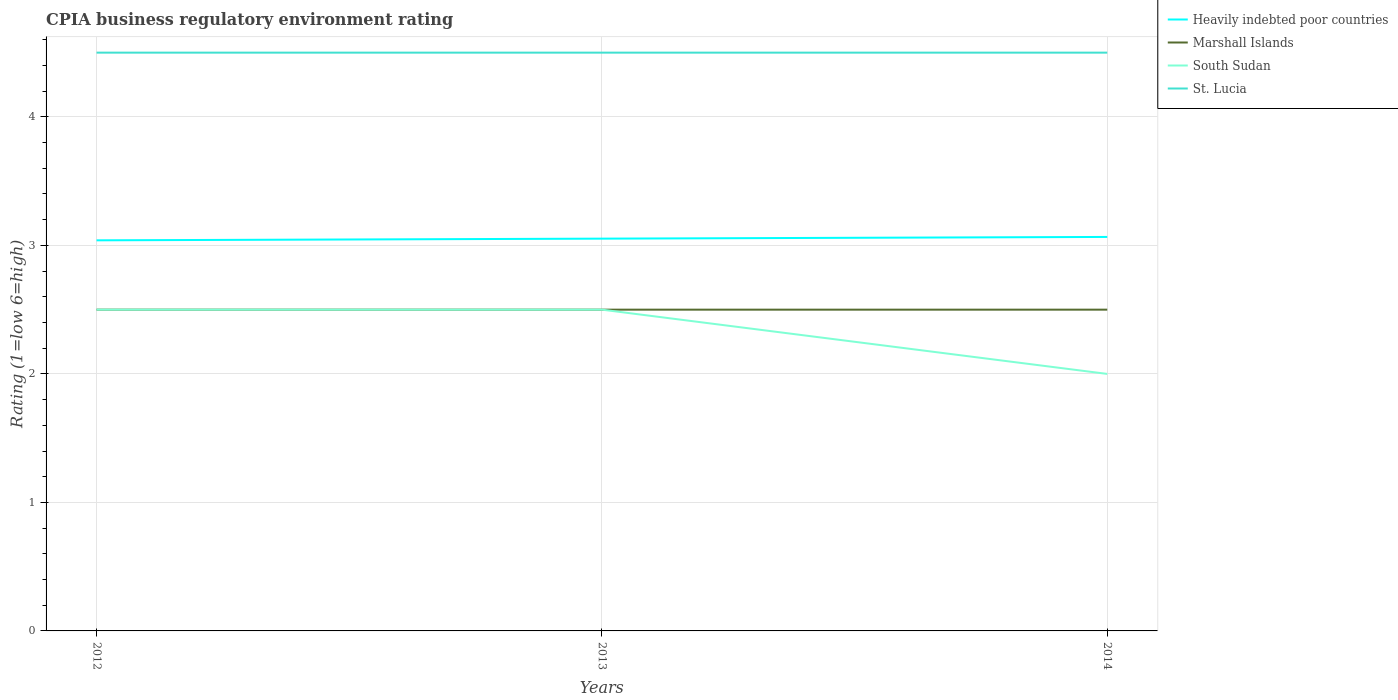How many different coloured lines are there?
Your answer should be very brief. 4. Does the line corresponding to St. Lucia intersect with the line corresponding to South Sudan?
Keep it short and to the point. No. Is the number of lines equal to the number of legend labels?
Offer a very short reply. Yes. Across all years, what is the maximum CPIA rating in Heavily indebted poor countries?
Make the answer very short. 3.04. What is the total CPIA rating in Heavily indebted poor countries in the graph?
Offer a terse response. -0.03. What is the difference between the highest and the second highest CPIA rating in Heavily indebted poor countries?
Keep it short and to the point. 0.03. Is the CPIA rating in Marshall Islands strictly greater than the CPIA rating in St. Lucia over the years?
Your answer should be very brief. Yes. How many lines are there?
Give a very brief answer. 4. How many years are there in the graph?
Your answer should be compact. 3. Does the graph contain any zero values?
Provide a succinct answer. No. Does the graph contain grids?
Give a very brief answer. Yes. Where does the legend appear in the graph?
Keep it short and to the point. Top right. How many legend labels are there?
Make the answer very short. 4. How are the legend labels stacked?
Give a very brief answer. Vertical. What is the title of the graph?
Your response must be concise. CPIA business regulatory environment rating. What is the label or title of the X-axis?
Give a very brief answer. Years. What is the Rating (1=low 6=high) in Heavily indebted poor countries in 2012?
Provide a short and direct response. 3.04. What is the Rating (1=low 6=high) of St. Lucia in 2012?
Offer a very short reply. 4.5. What is the Rating (1=low 6=high) of Heavily indebted poor countries in 2013?
Provide a succinct answer. 3.05. What is the Rating (1=low 6=high) in Marshall Islands in 2013?
Provide a short and direct response. 2.5. What is the Rating (1=low 6=high) of Heavily indebted poor countries in 2014?
Offer a terse response. 3.07. What is the Rating (1=low 6=high) in South Sudan in 2014?
Your answer should be very brief. 2. What is the Rating (1=low 6=high) in St. Lucia in 2014?
Your response must be concise. 4.5. Across all years, what is the maximum Rating (1=low 6=high) in Heavily indebted poor countries?
Offer a very short reply. 3.07. Across all years, what is the maximum Rating (1=low 6=high) in St. Lucia?
Provide a short and direct response. 4.5. Across all years, what is the minimum Rating (1=low 6=high) in Heavily indebted poor countries?
Your response must be concise. 3.04. Across all years, what is the minimum Rating (1=low 6=high) of South Sudan?
Make the answer very short. 2. Across all years, what is the minimum Rating (1=low 6=high) in St. Lucia?
Provide a succinct answer. 4.5. What is the total Rating (1=low 6=high) of Heavily indebted poor countries in the graph?
Make the answer very short. 9.16. What is the total Rating (1=low 6=high) in Marshall Islands in the graph?
Offer a terse response. 7.5. What is the total Rating (1=low 6=high) in South Sudan in the graph?
Provide a succinct answer. 7. What is the difference between the Rating (1=low 6=high) in Heavily indebted poor countries in 2012 and that in 2013?
Your answer should be compact. -0.01. What is the difference between the Rating (1=low 6=high) in Marshall Islands in 2012 and that in 2013?
Your answer should be very brief. 0. What is the difference between the Rating (1=low 6=high) in Heavily indebted poor countries in 2012 and that in 2014?
Offer a very short reply. -0.03. What is the difference between the Rating (1=low 6=high) of Marshall Islands in 2012 and that in 2014?
Your answer should be very brief. 0. What is the difference between the Rating (1=low 6=high) in South Sudan in 2012 and that in 2014?
Your answer should be very brief. 0.5. What is the difference between the Rating (1=low 6=high) in St. Lucia in 2012 and that in 2014?
Provide a short and direct response. 0. What is the difference between the Rating (1=low 6=high) in Heavily indebted poor countries in 2013 and that in 2014?
Your answer should be compact. -0.01. What is the difference between the Rating (1=low 6=high) in Marshall Islands in 2013 and that in 2014?
Offer a very short reply. 0. What is the difference between the Rating (1=low 6=high) of Heavily indebted poor countries in 2012 and the Rating (1=low 6=high) of Marshall Islands in 2013?
Your answer should be compact. 0.54. What is the difference between the Rating (1=low 6=high) of Heavily indebted poor countries in 2012 and the Rating (1=low 6=high) of South Sudan in 2013?
Keep it short and to the point. 0.54. What is the difference between the Rating (1=low 6=high) in Heavily indebted poor countries in 2012 and the Rating (1=low 6=high) in St. Lucia in 2013?
Your answer should be very brief. -1.46. What is the difference between the Rating (1=low 6=high) in Marshall Islands in 2012 and the Rating (1=low 6=high) in South Sudan in 2013?
Provide a short and direct response. 0. What is the difference between the Rating (1=low 6=high) in South Sudan in 2012 and the Rating (1=low 6=high) in St. Lucia in 2013?
Provide a succinct answer. -2. What is the difference between the Rating (1=low 6=high) in Heavily indebted poor countries in 2012 and the Rating (1=low 6=high) in Marshall Islands in 2014?
Your answer should be very brief. 0.54. What is the difference between the Rating (1=low 6=high) of Heavily indebted poor countries in 2012 and the Rating (1=low 6=high) of South Sudan in 2014?
Make the answer very short. 1.04. What is the difference between the Rating (1=low 6=high) in Heavily indebted poor countries in 2012 and the Rating (1=low 6=high) in St. Lucia in 2014?
Give a very brief answer. -1.46. What is the difference between the Rating (1=low 6=high) of Marshall Islands in 2012 and the Rating (1=low 6=high) of South Sudan in 2014?
Make the answer very short. 0.5. What is the difference between the Rating (1=low 6=high) of Marshall Islands in 2012 and the Rating (1=low 6=high) of St. Lucia in 2014?
Make the answer very short. -2. What is the difference between the Rating (1=low 6=high) of Heavily indebted poor countries in 2013 and the Rating (1=low 6=high) of Marshall Islands in 2014?
Offer a terse response. 0.55. What is the difference between the Rating (1=low 6=high) in Heavily indebted poor countries in 2013 and the Rating (1=low 6=high) in South Sudan in 2014?
Provide a succinct answer. 1.05. What is the difference between the Rating (1=low 6=high) of Heavily indebted poor countries in 2013 and the Rating (1=low 6=high) of St. Lucia in 2014?
Make the answer very short. -1.45. What is the difference between the Rating (1=low 6=high) of Marshall Islands in 2013 and the Rating (1=low 6=high) of South Sudan in 2014?
Ensure brevity in your answer.  0.5. What is the difference between the Rating (1=low 6=high) of Marshall Islands in 2013 and the Rating (1=low 6=high) of St. Lucia in 2014?
Ensure brevity in your answer.  -2. What is the difference between the Rating (1=low 6=high) in South Sudan in 2013 and the Rating (1=low 6=high) in St. Lucia in 2014?
Provide a succinct answer. -2. What is the average Rating (1=low 6=high) of Heavily indebted poor countries per year?
Keep it short and to the point. 3.05. What is the average Rating (1=low 6=high) of Marshall Islands per year?
Your response must be concise. 2.5. What is the average Rating (1=low 6=high) in South Sudan per year?
Ensure brevity in your answer.  2.33. What is the average Rating (1=low 6=high) in St. Lucia per year?
Your response must be concise. 4.5. In the year 2012, what is the difference between the Rating (1=low 6=high) of Heavily indebted poor countries and Rating (1=low 6=high) of Marshall Islands?
Offer a terse response. 0.54. In the year 2012, what is the difference between the Rating (1=low 6=high) of Heavily indebted poor countries and Rating (1=low 6=high) of South Sudan?
Your answer should be compact. 0.54. In the year 2012, what is the difference between the Rating (1=low 6=high) of Heavily indebted poor countries and Rating (1=low 6=high) of St. Lucia?
Ensure brevity in your answer.  -1.46. In the year 2013, what is the difference between the Rating (1=low 6=high) of Heavily indebted poor countries and Rating (1=low 6=high) of Marshall Islands?
Keep it short and to the point. 0.55. In the year 2013, what is the difference between the Rating (1=low 6=high) of Heavily indebted poor countries and Rating (1=low 6=high) of South Sudan?
Your answer should be very brief. 0.55. In the year 2013, what is the difference between the Rating (1=low 6=high) of Heavily indebted poor countries and Rating (1=low 6=high) of St. Lucia?
Offer a terse response. -1.45. In the year 2013, what is the difference between the Rating (1=low 6=high) of Marshall Islands and Rating (1=low 6=high) of St. Lucia?
Give a very brief answer. -2. In the year 2014, what is the difference between the Rating (1=low 6=high) in Heavily indebted poor countries and Rating (1=low 6=high) in Marshall Islands?
Your answer should be compact. 0.57. In the year 2014, what is the difference between the Rating (1=low 6=high) of Heavily indebted poor countries and Rating (1=low 6=high) of South Sudan?
Your response must be concise. 1.07. In the year 2014, what is the difference between the Rating (1=low 6=high) in Heavily indebted poor countries and Rating (1=low 6=high) in St. Lucia?
Make the answer very short. -1.43. In the year 2014, what is the difference between the Rating (1=low 6=high) of Marshall Islands and Rating (1=low 6=high) of South Sudan?
Provide a short and direct response. 0.5. What is the ratio of the Rating (1=low 6=high) in Marshall Islands in 2012 to that in 2013?
Offer a very short reply. 1. What is the ratio of the Rating (1=low 6=high) of St. Lucia in 2012 to that in 2013?
Provide a short and direct response. 1. What is the ratio of the Rating (1=low 6=high) of Heavily indebted poor countries in 2012 to that in 2014?
Provide a short and direct response. 0.99. What is the ratio of the Rating (1=low 6=high) of Marshall Islands in 2012 to that in 2014?
Keep it short and to the point. 1. What is the ratio of the Rating (1=low 6=high) of South Sudan in 2012 to that in 2014?
Provide a succinct answer. 1.25. What is the ratio of the Rating (1=low 6=high) of St. Lucia in 2012 to that in 2014?
Give a very brief answer. 1. What is the ratio of the Rating (1=low 6=high) of Heavily indebted poor countries in 2013 to that in 2014?
Keep it short and to the point. 1. What is the ratio of the Rating (1=low 6=high) of Marshall Islands in 2013 to that in 2014?
Give a very brief answer. 1. What is the ratio of the Rating (1=low 6=high) in South Sudan in 2013 to that in 2014?
Ensure brevity in your answer.  1.25. What is the ratio of the Rating (1=low 6=high) in St. Lucia in 2013 to that in 2014?
Make the answer very short. 1. What is the difference between the highest and the second highest Rating (1=low 6=high) of Heavily indebted poor countries?
Keep it short and to the point. 0.01. What is the difference between the highest and the second highest Rating (1=low 6=high) of Marshall Islands?
Provide a succinct answer. 0. What is the difference between the highest and the second highest Rating (1=low 6=high) of South Sudan?
Give a very brief answer. 0. What is the difference between the highest and the lowest Rating (1=low 6=high) in Heavily indebted poor countries?
Give a very brief answer. 0.03. 